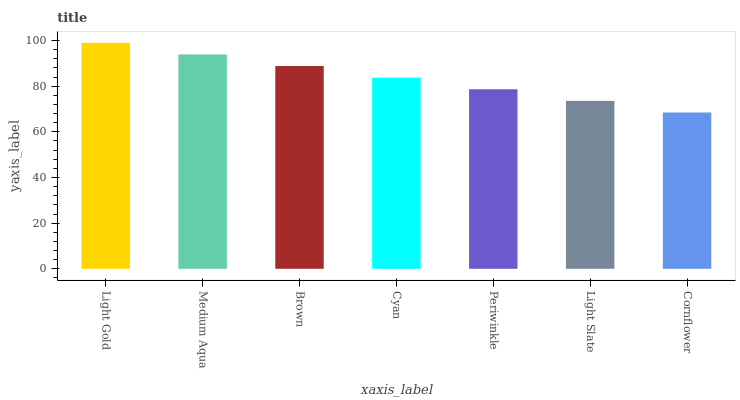Is Cornflower the minimum?
Answer yes or no. Yes. Is Light Gold the maximum?
Answer yes or no. Yes. Is Medium Aqua the minimum?
Answer yes or no. No. Is Medium Aqua the maximum?
Answer yes or no. No. Is Light Gold greater than Medium Aqua?
Answer yes or no. Yes. Is Medium Aqua less than Light Gold?
Answer yes or no. Yes. Is Medium Aqua greater than Light Gold?
Answer yes or no. No. Is Light Gold less than Medium Aqua?
Answer yes or no. No. Is Cyan the high median?
Answer yes or no. Yes. Is Cyan the low median?
Answer yes or no. Yes. Is Cornflower the high median?
Answer yes or no. No. Is Cornflower the low median?
Answer yes or no. No. 